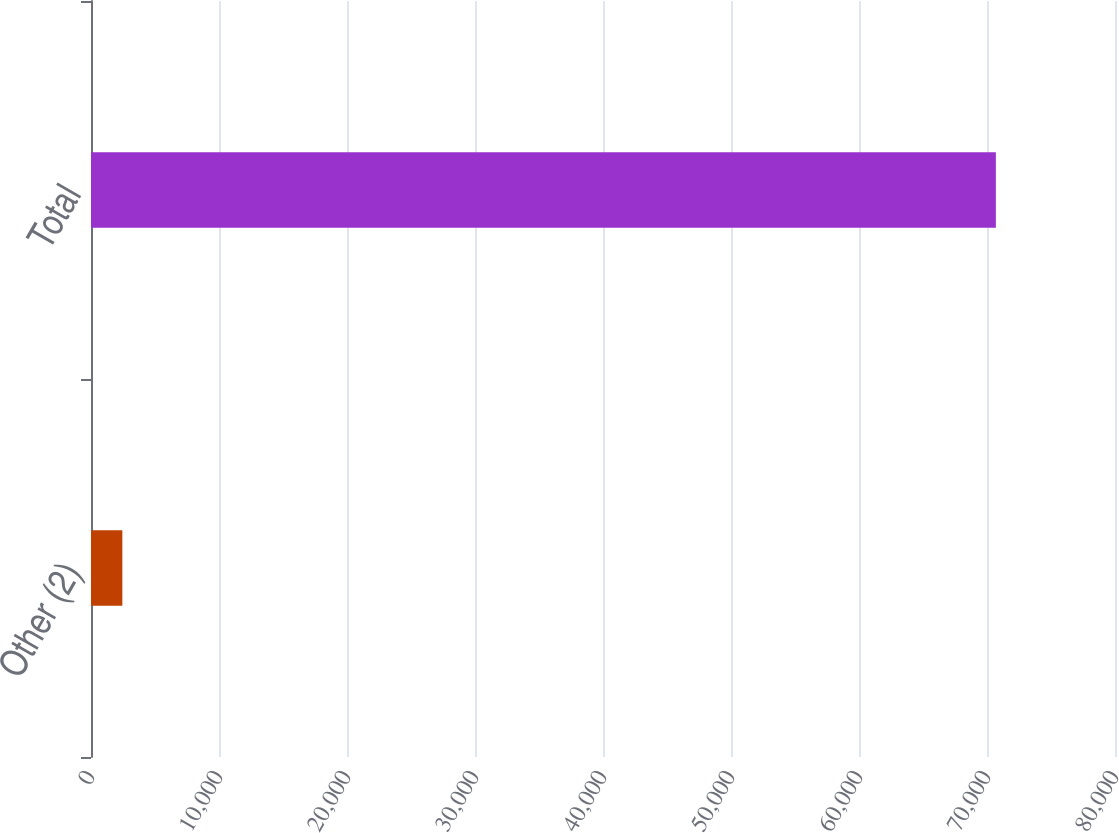Convert chart. <chart><loc_0><loc_0><loc_500><loc_500><bar_chart><fcel>Other (2)<fcel>Total<nl><fcel>2448<fcel>70693<nl></chart> 